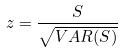<formula> <loc_0><loc_0><loc_500><loc_500>z = \frac { S } { \sqrt { V A R ( S ) } }</formula> 